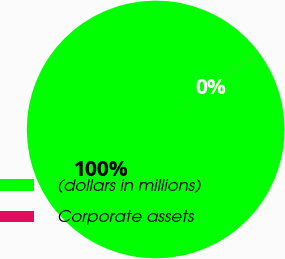<chart> <loc_0><loc_0><loc_500><loc_500><pie_chart><fcel>(dollars in millions)<fcel>Corporate assets<nl><fcel>99.98%<fcel>0.02%<nl></chart> 